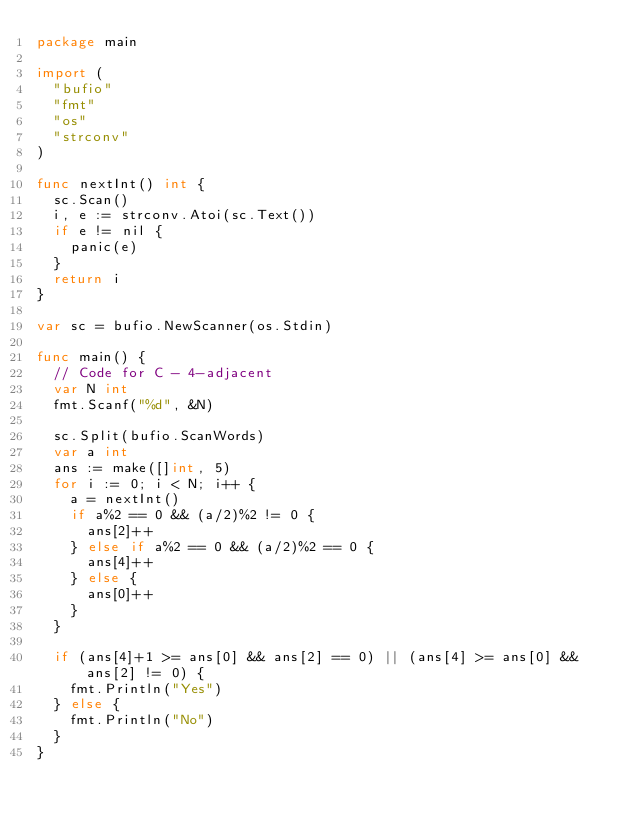<code> <loc_0><loc_0><loc_500><loc_500><_Go_>package main

import (
	"bufio"
	"fmt"
	"os"
	"strconv"
)

func nextInt() int {
	sc.Scan()
	i, e := strconv.Atoi(sc.Text())
	if e != nil {
		panic(e)
	}
	return i
}

var sc = bufio.NewScanner(os.Stdin)

func main() {
	// Code for C - 4-adjacent
	var N int
	fmt.Scanf("%d", &N)

	sc.Split(bufio.ScanWords)
	var a int
	ans := make([]int, 5)
	for i := 0; i < N; i++ {
		a = nextInt()
		if a%2 == 0 && (a/2)%2 != 0 {
			ans[2]++
		} else if a%2 == 0 && (a/2)%2 == 0 {
			ans[4]++
		} else {
			ans[0]++
		}
	}

	if (ans[4]+1 >= ans[0] && ans[2] == 0) || (ans[4] >= ans[0] && ans[2] != 0) {
		fmt.Println("Yes")
	} else {
		fmt.Println("No")
	}
}
</code> 